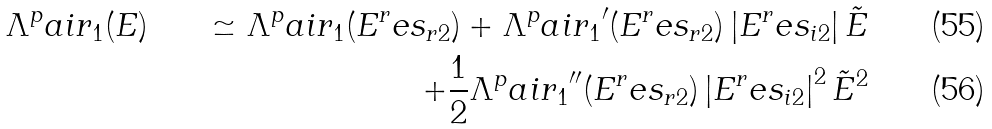Convert formula to latex. <formula><loc_0><loc_0><loc_500><loc_500>\Lambda ^ { p } a i r _ { 1 } ( E ) & & \simeq \Lambda ^ { p } a i r _ { 1 } ( E ^ { r } e s _ { r 2 } ) + { \Lambda ^ { p } a i r _ { 1 } } ^ { \prime } ( E ^ { r } e s _ { r 2 } ) \left | E ^ { r } e s _ { i 2 } \right | \tilde { E } \\ & & + \frac { 1 } { 2 } { \Lambda ^ { p } a i r _ { 1 } } ^ { \prime \prime } ( E ^ { r } e s _ { r 2 } ) \left | E ^ { r } e s _ { i 2 } \right | ^ { 2 } \tilde { E } ^ { 2 }</formula> 